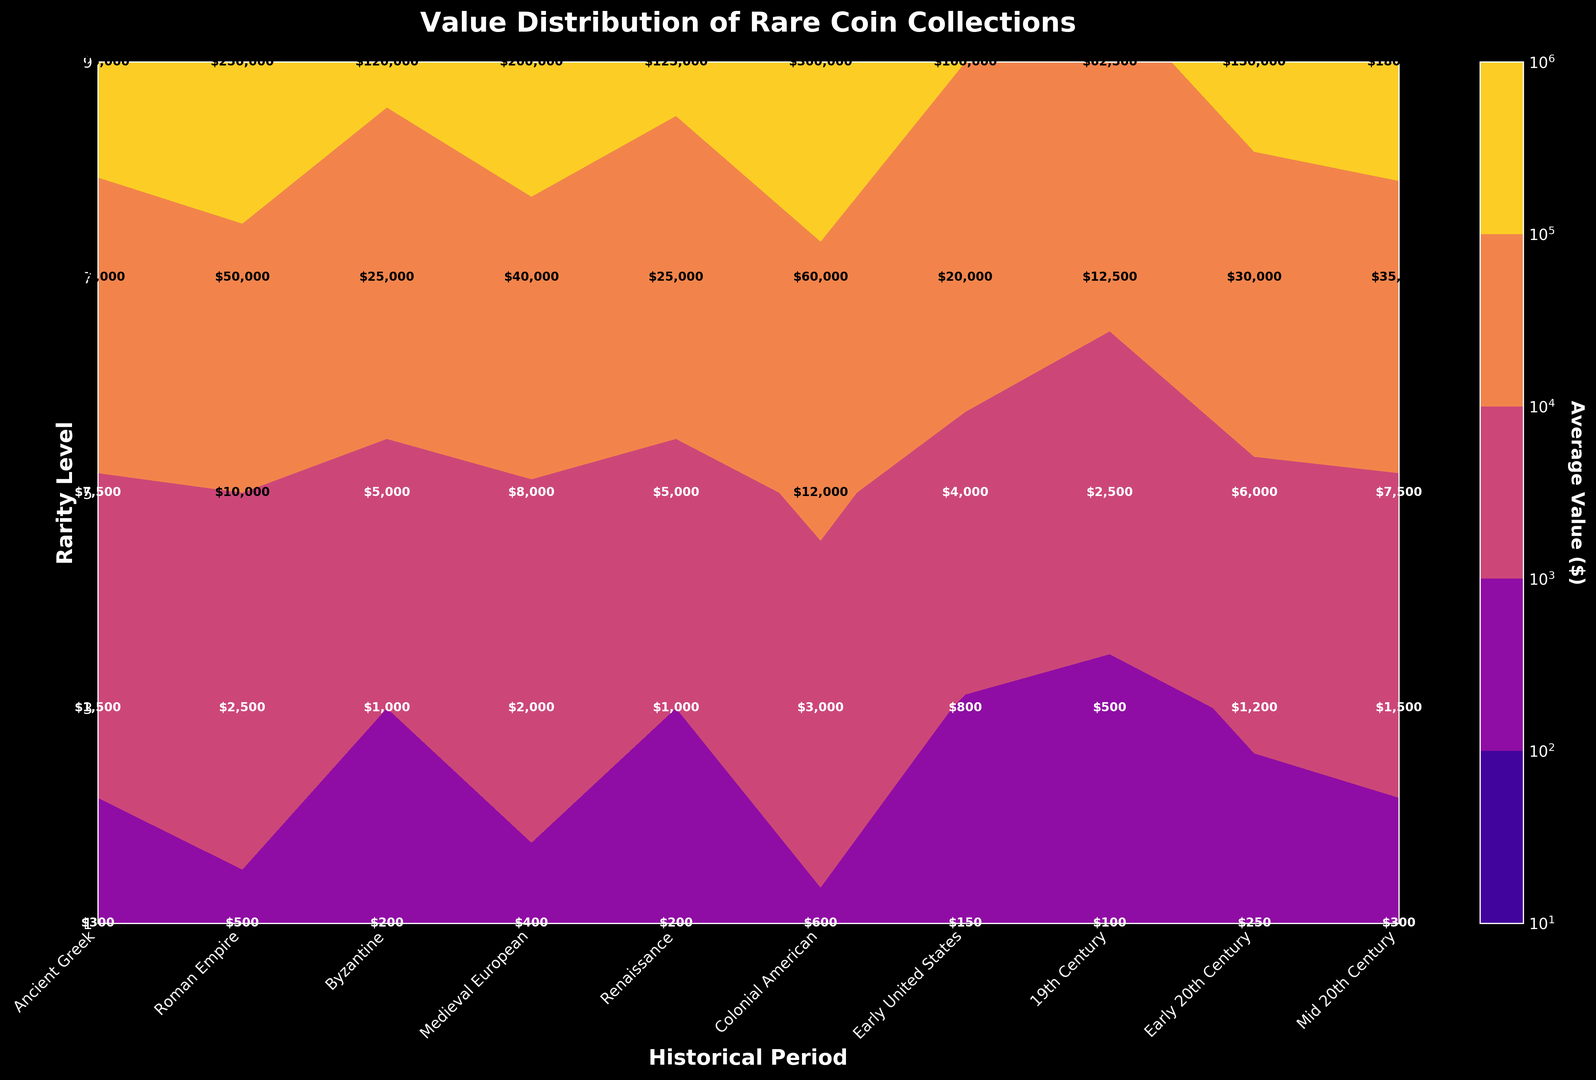Which historical period has the highest average value for the rarest coins (Rarity Level 9)? Look at the contour where Rarity Level is 9 and scan across all historical periods. The highest value is where the color is darkest or the label has the highest number.
Answer: Early United States What is the difference in average value between Rarity Level 1 and Rarity Level 9 in the Renaissance period? Find the values for Rarity Level 1 and Rarity Level 9 within the Renaissance period. Subtract the value of Rarity Level 1 from that of Rarity Level 9. Values are 250 and 150,000 respectively, so the difference is 150,000 - 250.
Answer: 149,750 How does the average value for Rarity Level 7 in the Ancient Greek period compare to the same rarity level in the Roman Empire period? Check the value on the contour plot for Rarity Level 7 in both the Ancient Greek and Roman Empire periods. Compare the numerical values. Ancient Greek is 50,000, and Roman Empire is 35,000. 50,000 is higher than 35,000.
Answer: Higher in Ancient Greek What's the average value for Rarity Level 5 coins across all historical periods? Sum all the values for Rarity Level 5 across each historical period and divide by the number of periods. Values are 10,000, 7,500, 5,000, 4,000, 6,000, 8,000, 12,000, 7,500, 5,000, and 2,500. The sum is 68,500 divided by 10 periods.
Answer: 6,850 Which rarity level has the least variation in average value among all historical periods? For each rarity level, calculate the range (subtract minimum value from maximum value) across all periods. The rarity level with the smallest range has the least variation. Maximum and minimum values for each level show the least variation in Rarity Level 1.
Answer: Rarity Level 1 What trends are visible in the average values of rare coins across historical periods as the rarity level increases? Observe the contour colors and average values from left (Ancient Greek) to right (Mid 20th Century) as the rarity level goes from 1 to 9. As the rarity level increases, average values tend to generally increase across all periods.
Answer: Increasing trend Which historical period has the lowest average value for Rarity Level 3 coins? Look at the value labels for Rarity Level 3 across all historical periods. The lowest value corresponds to the lightest color/shading in a dark background plot.
Answer: Mid 20th Century If a coin collector only wants coins valued over $50,000, which rarity levels and historical periods should they consider? Scan the contour plot for values over $50,000. These occur at higher rarity levels (7 and 9) in most historical periods, notably from Ancient Greek to Early United States.
Answer: Rarity Levels 7 and 9; periods: Ancient Greek to Early United States 